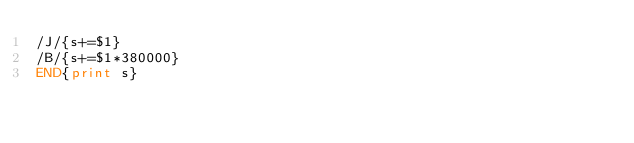<code> <loc_0><loc_0><loc_500><loc_500><_Awk_>/J/{s+=$1}
/B/{s+=$1*380000}
END{print s}</code> 